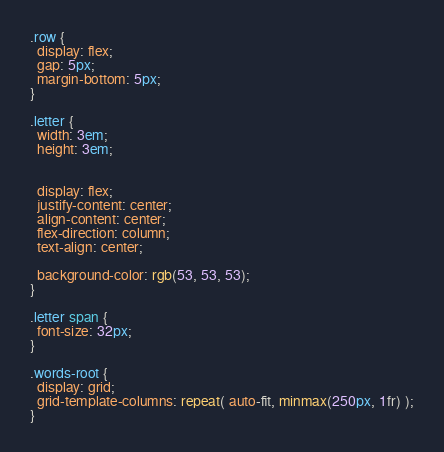Convert code to text. <code><loc_0><loc_0><loc_500><loc_500><_CSS_>.row {
  display: flex;
  gap: 5px;
  margin-bottom: 5px;
}

.letter {
  width: 3em;
  height: 3em;


  display: flex;
  justify-content: center;
  align-content: center;
  flex-direction: column;
  text-align: center;

  background-color: rgb(53, 53, 53);
}

.letter span {
  font-size: 32px;
}

.words-root {
  display: grid;
  grid-template-columns: repeat( auto-fit, minmax(250px, 1fr) );
}</code> 